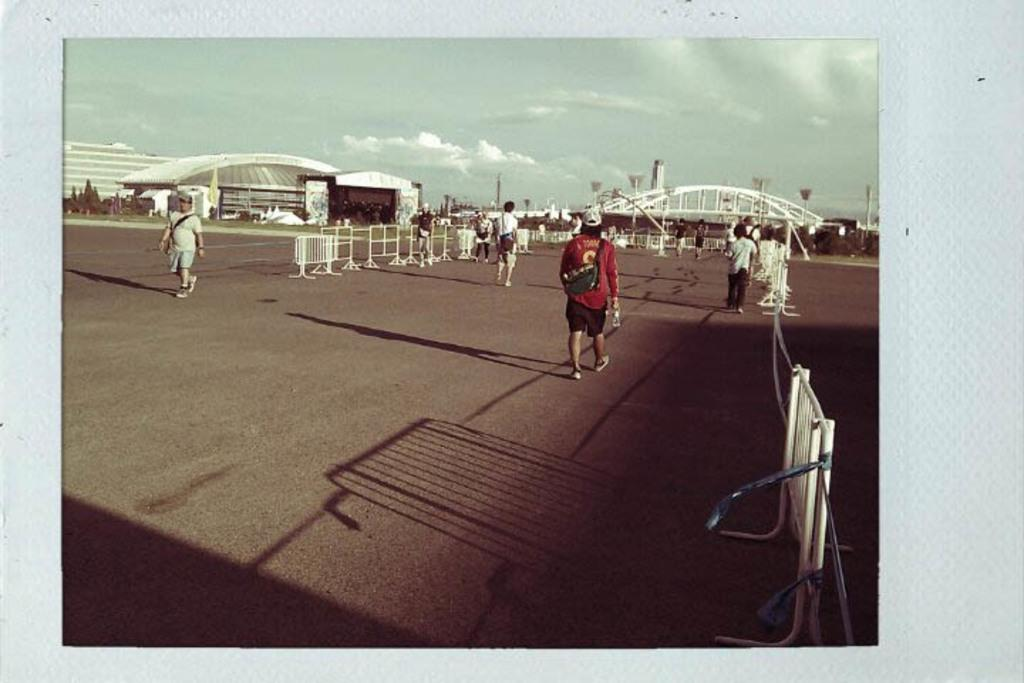What type of structures can be seen in the image? There are buildings in the image. What other natural elements are present in the image? There are trees in the image. What kind of barrier can be seen in the image? There is a fence in the image. What are the people in the image doing? People are walking on the road in the image. How would you describe the sky in the image? The sky is clouded in the image. What type of feeling can be seen in the image? There is no feeling present in the image; it is a visual representation of structures, trees, a fence, people walking, and the sky. Can you tell me where the basin is located in the image? There is no basin present in the image. 